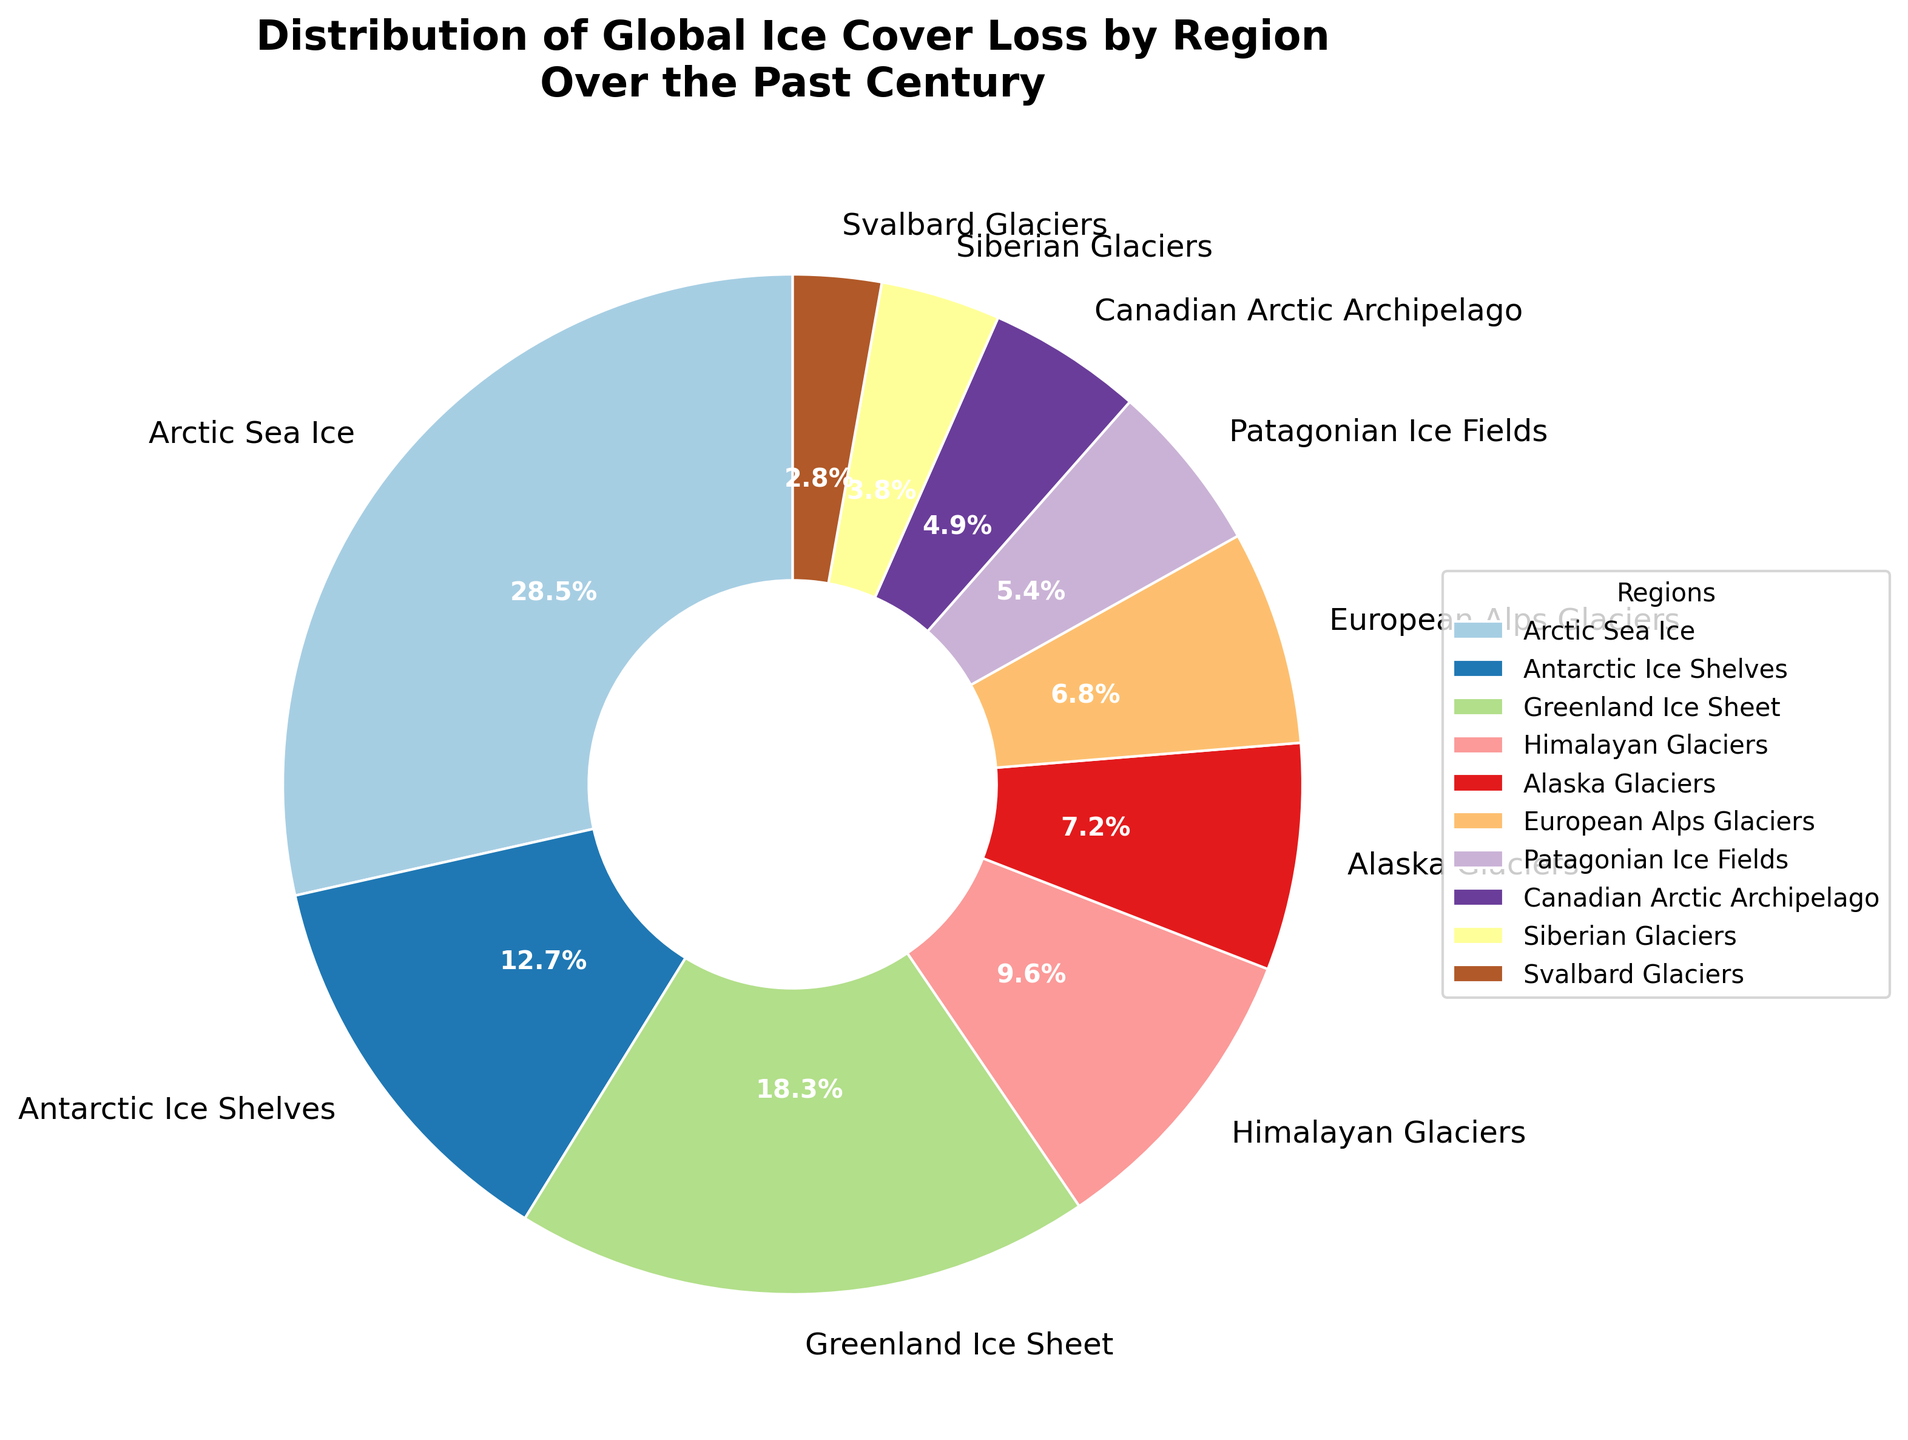What region has the largest percentage of global ice cover loss? The slice of the pie with the largest value is labeled "Arctic Sea Ice," which represents 28.5%.
Answer: Arctic Sea Ice What regions combined account for more than 50% of the global ice cover loss? Adding the percentages, Arctic Sea Ice (28.5%) + Greenland Ice Sheet (18.3%) + Antarctic Ice Shelves (12.7%) = 59.5%, which is more than 50%.
Answer: Arctic Sea Ice, Greenland Ice Sheet, Antarctic Ice Shelves Which region has lost less ice cover, the European Alps Glaciers or the Alaskan Glaciers? Comparing the percentages, European Alps Glaciers (6.8%) are less than Alaska Glaciers (7.2%).
Answer: European Alps Glaciers Do the Alaskan Glaciers and the Patagonian Ice Fields together account for more or less than 15% of global ice cover loss? Adding the percentages, Alaska Glaciers (7.2%) + Patagonian Ice Fields (5.4%) = 12.6%, which is less than 15%.
Answer: Less than 15% Which region has the smallest percentage of global ice cover loss? The smallest slice of the pie labeled "Svalbard Glaciers" represents 2.8%.
Answer: Svalbard Glaciers What is the combined percentage of ice cover loss for Himalayan Glaciers, Canadian Arctic Archipelago, and Siberian Glaciers? Adding the percentages, Himalayan Glaciers (9.6%) + Canadian Arctic Archipelago (4.9%) + Siberian Glaciers (3.8%) = 18.3%.
Answer: 18.3% Which regions have an ice cover loss percentage closest to each other? European Alps Glaciers (6.8%) and Alaska Glaciers (7.2%) have percentages that are very close.
Answer: European Alps Glaciers and Alaska Glaciers What is the difference in ice cover loss percentage between the Greenland Ice Sheet and the Himalayan Glaciers? Subtracting the smaller percentage from the larger one, Greenland Ice Sheet (18.3%) - Himalayan Glaciers (9.6%) = 8.7%.
Answer: 8.7% Which regions have less than 5% of global ice cover loss? The regions are Canadian Arctic Archipelago (4.9%), Siberian Glaciers (3.8%), and Svalbard Glaciers (2.8%), all of which are less than 5%.
Answer: Canadian Arctic Archipelago, Siberian Glaciers, Svalbard Glaciers What is the sum of the ice cover loss percentages for regions outside the top three largest loss regions? First, identify the top three: Arctic Sea Ice (28.5%), Greenland Ice Sheet (18.3%), and Antarctic Ice Shelves (12.7%). Summing the remaining percentages: Himalayan Glaciers (9.6%) + Alaska Glaciers (7.2%) + European Alps Glaciers (6.8%) + Patagonian Ice Fields (5.4%) + Canadian Arctic Archipelago (4.9%) + Siberian Glaciers (3.8%) + Svalbard Glaciers (2.8%) = 40.5%.
Answer: 40.5% 